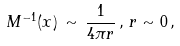<formula> <loc_0><loc_0><loc_500><loc_500>M ^ { - 1 } ( x ) \, \sim \, \frac { 1 } { 4 \pi r } \, , \, r \sim 0 \, ,</formula> 